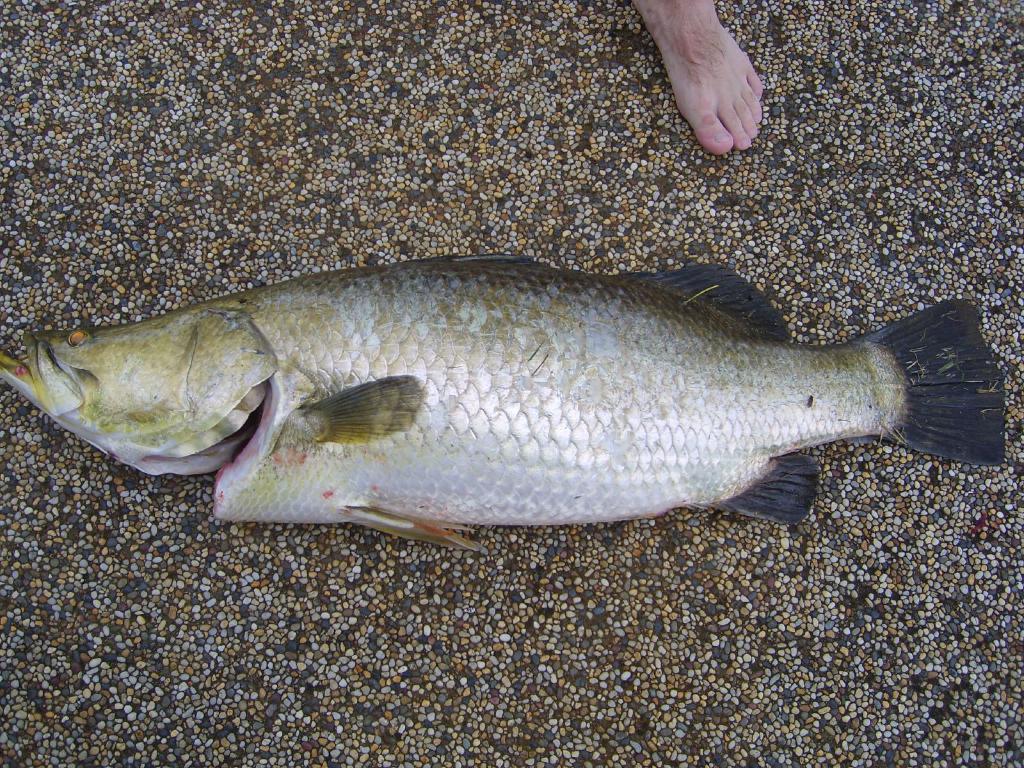In one or two sentences, can you explain what this image depicts? In this image in the middle, there is a fish. At the top there is a person leg. In the background there are stones. 